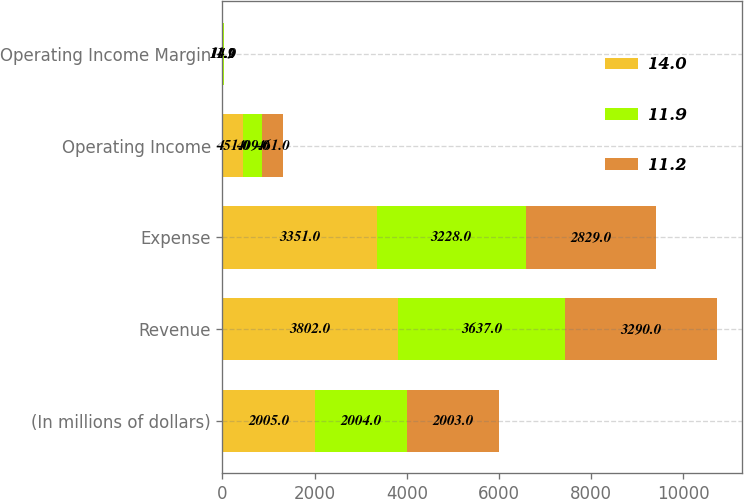Convert chart to OTSL. <chart><loc_0><loc_0><loc_500><loc_500><stacked_bar_chart><ecel><fcel>(In millions of dollars)<fcel>Revenue<fcel>Expense<fcel>Operating Income<fcel>Operating Income Margin<nl><fcel>14<fcel>2005<fcel>3802<fcel>3351<fcel>451<fcel>11.9<nl><fcel>11.9<fcel>2004<fcel>3637<fcel>3228<fcel>409<fcel>11.2<nl><fcel>11.2<fcel>2003<fcel>3290<fcel>2829<fcel>461<fcel>14<nl></chart> 